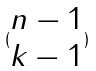<formula> <loc_0><loc_0><loc_500><loc_500>( \begin{matrix} n - 1 \\ k - 1 \end{matrix} )</formula> 